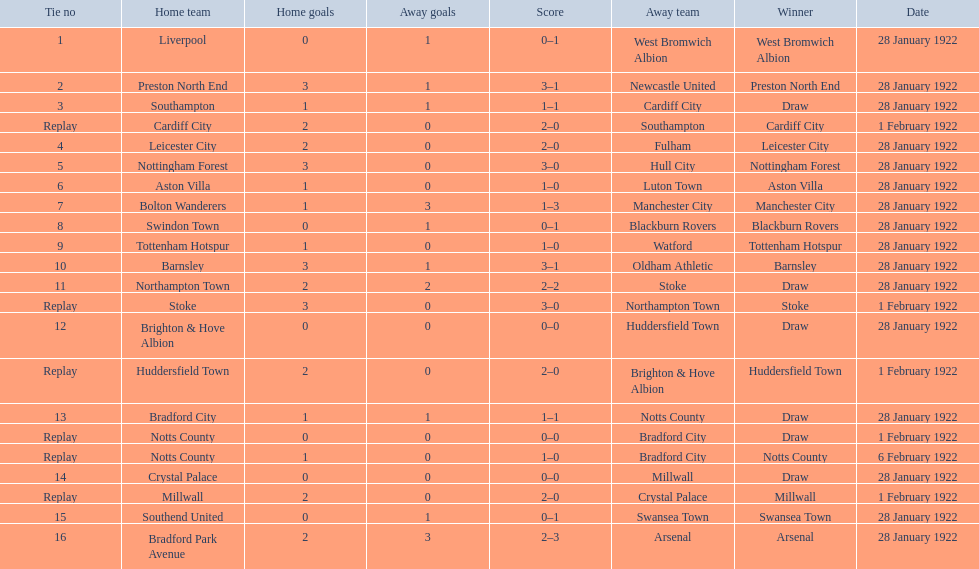What are all of the home teams? Liverpool, Preston North End, Southampton, Cardiff City, Leicester City, Nottingham Forest, Aston Villa, Bolton Wanderers, Swindon Town, Tottenham Hotspur, Barnsley, Northampton Town, Stoke, Brighton & Hove Albion, Huddersfield Town, Bradford City, Notts County, Notts County, Crystal Palace, Millwall, Southend United, Bradford Park Avenue. What were the scores? 0–1, 3–1, 1–1, 2–0, 2–0, 3–0, 1–0, 1–3, 0–1, 1–0, 3–1, 2–2, 3–0, 0–0, 2–0, 1–1, 0–0, 1–0, 0–0, 2–0, 0–1, 2–3. On which dates did they play? 28 January 1922, 28 January 1922, 28 January 1922, 1 February 1922, 28 January 1922, 28 January 1922, 28 January 1922, 28 January 1922, 28 January 1922, 28 January 1922, 28 January 1922, 28 January 1922, 1 February 1922, 28 January 1922, 1 February 1922, 28 January 1922, 1 February 1922, 6 February 1922, 28 January 1922, 1 February 1922, 28 January 1922, 28 January 1922. Which teams played on 28 january 1922? Liverpool, Preston North End, Southampton, Leicester City, Nottingham Forest, Aston Villa, Bolton Wanderers, Swindon Town, Tottenham Hotspur, Barnsley, Northampton Town, Brighton & Hove Albion, Bradford City, Crystal Palace, Southend United, Bradford Park Avenue. Of those, which scored the same as aston villa? Tottenham Hotspur. 